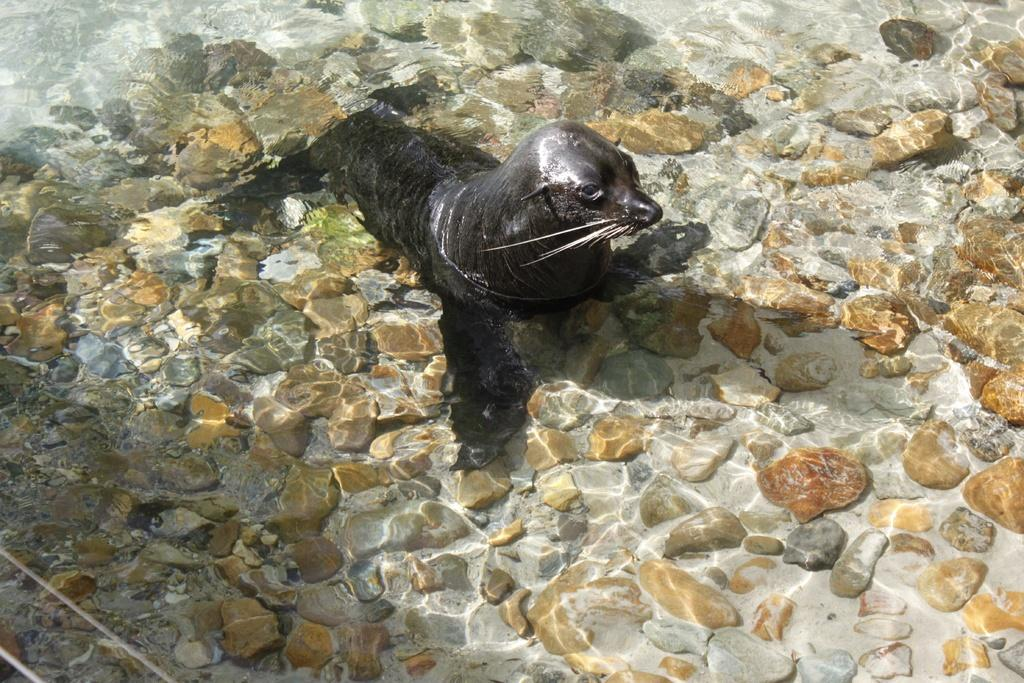What type of animal is in the image? There is a black colored seal in the image. Where is the seal located? The seal is in the water. What can be seen beneath the water? The surface beneath the water appears to be rocky. What type of mailbox can be seen near the seal in the image? There is no mailbox present in the image; it features a black colored seal in the water with a rocky surface beneath. 